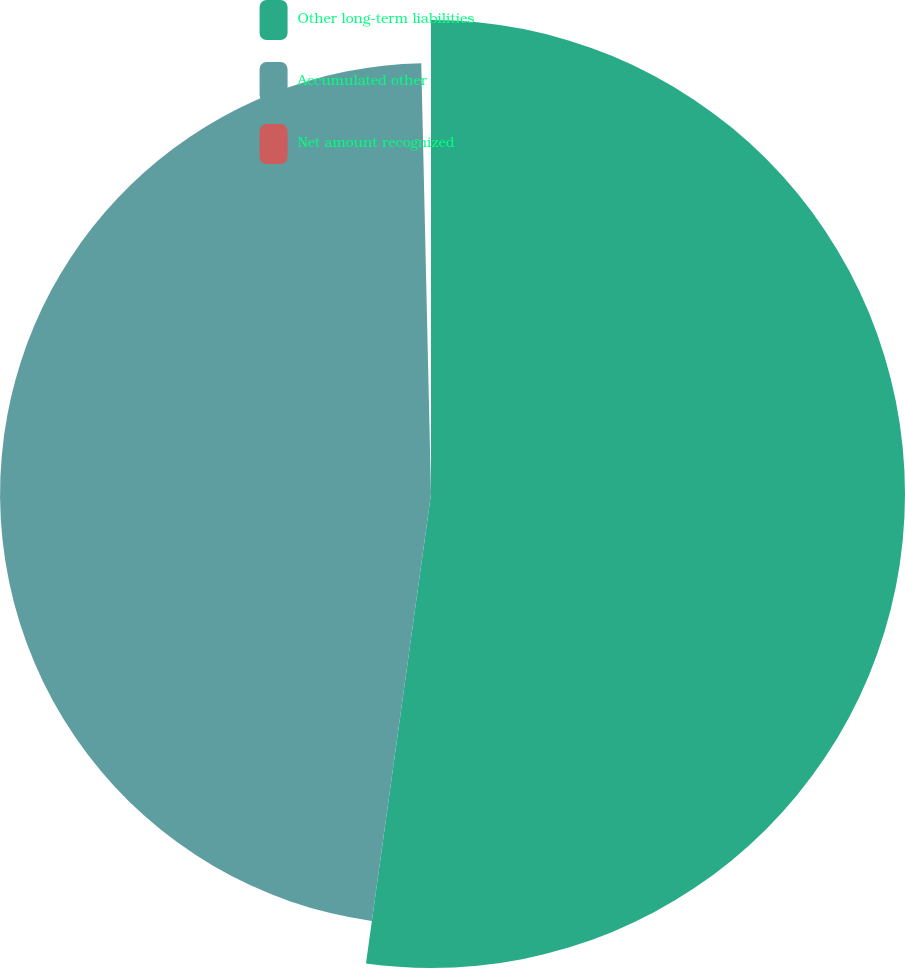Convert chart to OTSL. <chart><loc_0><loc_0><loc_500><loc_500><pie_chart><fcel>Other long-term liabilities<fcel>Accumulated other<fcel>Net amount recognized<nl><fcel>52.19%<fcel>47.45%<fcel>0.36%<nl></chart> 